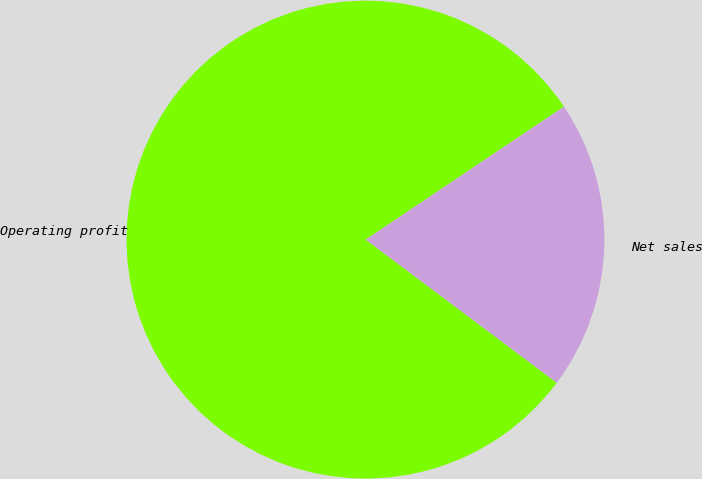<chart> <loc_0><loc_0><loc_500><loc_500><pie_chart><fcel>Net sales<fcel>Operating profit<nl><fcel>19.64%<fcel>80.36%<nl></chart> 